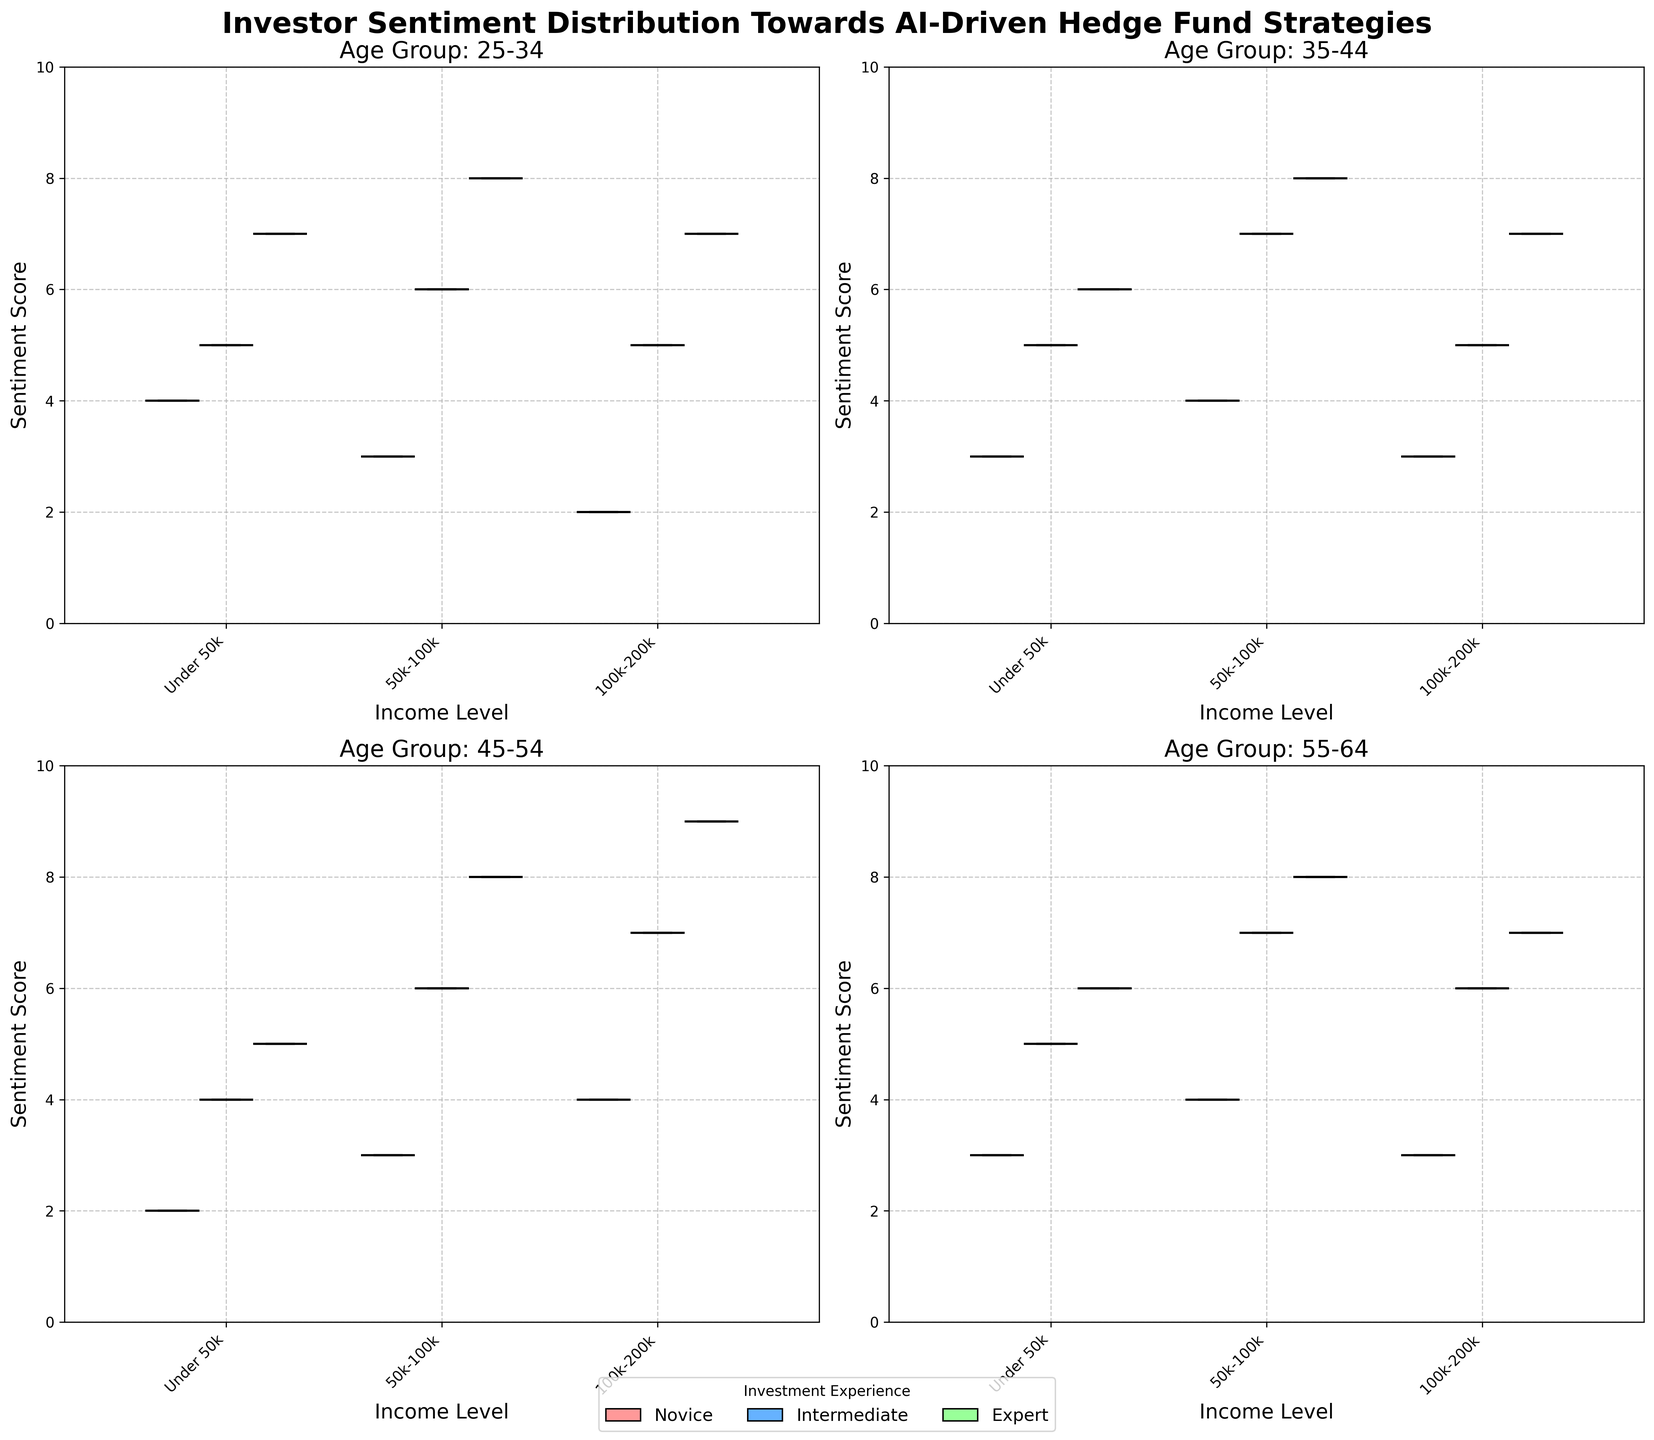What is the title of the figure? The title is located at the top of the figure and summarizes the subject of the data presented.
Answer: Investor Sentiment Distribution Towards AI-Driven Hedge Fund Strategies What are the income levels displayed on the x-axis? The x-axis labels indicate the different income groups being compared across the box plots.
Answer: Under 50k, 50k-100k, 100k-200k Which age group has the highest median sentiment score for experts with an income of 50k-100k? By comparing the median lines of the box plots for experts within the income level of 50k-100k, we observe which age group's median line is the highest.
Answer: Age Group 25-34 Is the sentiment score range for intermediates with an income of under 50k wider for the 35-44 age group than the 45-54 age group? Check the range between the whiskers of the box plots for intermediates within the under 50k income category for both age groups and compare.
Answer: No How does the interquartile range (IQR) for novices with an income level of 100k-200k compare across different age groups? Calculate the IQR (the range between the 25th and 75th percentiles) for each box plot representing novices in the 100k-200k income level across all age groups and compare these values.
Answer: Similar ranges Which age group shows the smallest variance in sentiment scores for experts with a 100k-200k income level? Compare the spread of the box plots and whiskers for experts in the 100k-200k income group across all age groups to identify the one with the smallest variance.
Answer: Age Group 35-44 Among the age groups shown, which has the highest variation in sentiment scores for intermediates with a 50k-100k income level? Observe the range between the whiskers and the size of the box for intermediates within the 50k-100k income bracket across different age groups to identify the one with the largest variation.
Answer: Age Group 25-34 What color represents novice investors on the plot, and what does it signify? Identify the color used to fill the box plots for novice investors and explain its significance.
Answer: #FF9999, representing novice investors 